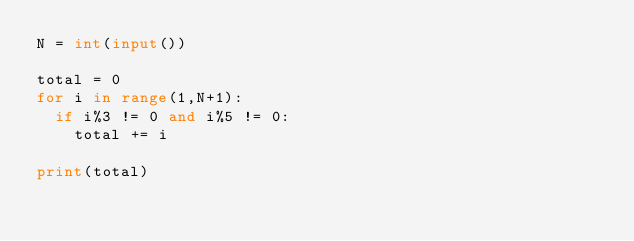Convert code to text. <code><loc_0><loc_0><loc_500><loc_500><_Python_>N = int(input())

total = 0
for i in range(1,N+1):
  if i%3 != 0 and i%5 != 0:
    total += i
    
print(total) </code> 